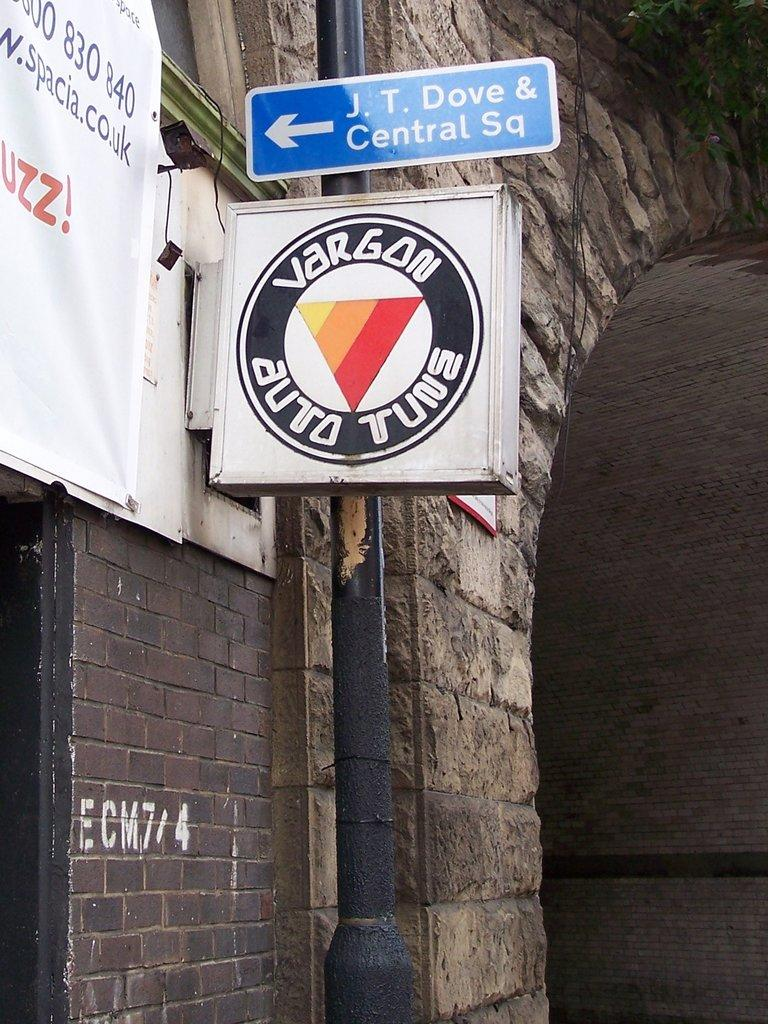<image>
Offer a succinct explanation of the picture presented. A round sign says Vargon Auto Tune on it. 